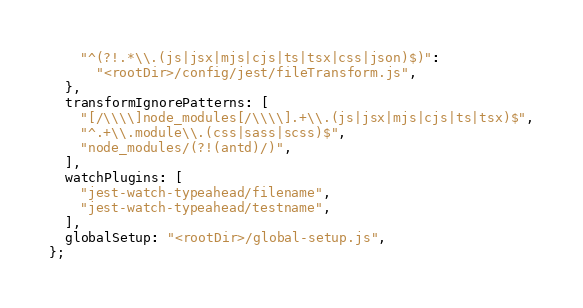<code> <loc_0><loc_0><loc_500><loc_500><_JavaScript_>    "^(?!.*\\.(js|jsx|mjs|cjs|ts|tsx|css|json)$)":
      "<rootDir>/config/jest/fileTransform.js",
  },
  transformIgnorePatterns: [
    "[/\\\\]node_modules[/\\\\].+\\.(js|jsx|mjs|cjs|ts|tsx)$",
    "^.+\\.module\\.(css|sass|scss)$",
    "node_modules/(?!(antd)/)",
  ],
  watchPlugins: [
    "jest-watch-typeahead/filename",
    "jest-watch-typeahead/testname",
  ],
  globalSetup: "<rootDir>/global-setup.js",
};
</code> 